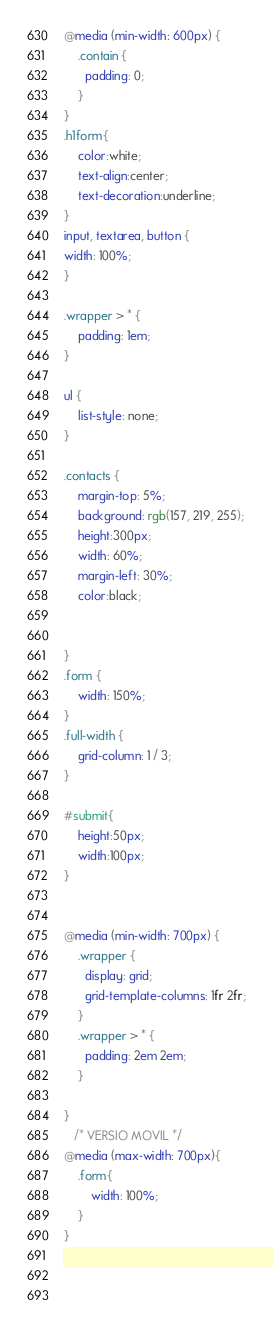<code> <loc_0><loc_0><loc_500><loc_500><_CSS_>@media (min-width: 600px) {
    .contain {
      padding: 0;
    }
}
.h1form{
    color:white;
    text-align:center;
    text-decoration:underline;
}
input, textarea, button {
width: 100%;
}

.wrapper > * {
    padding: 1em;
}
 
ul {
    list-style: none;
}
  
.contacts {
    margin-top: 5%;
    background: rgb(157, 219, 255);
    height:300px;
    width: 60%;
    margin-left: 30%;
    color:black;


}
.form {
    width: 150%;
}
.full-width {
    grid-column: 1 / 3;
}

#submit{
    height:50px; 
    width:100px;
}

  
@media (min-width: 700px) {
    .wrapper {
      display: grid;
      grid-template-columns: 1fr 2fr;
    }
    .wrapper > * {
      padding: 2em 2em;
    }
    
}
   /* VERSIO MOVIL */
@media (max-width: 700px){
    .form{
        width: 100%;
    }
}
  

  </code> 